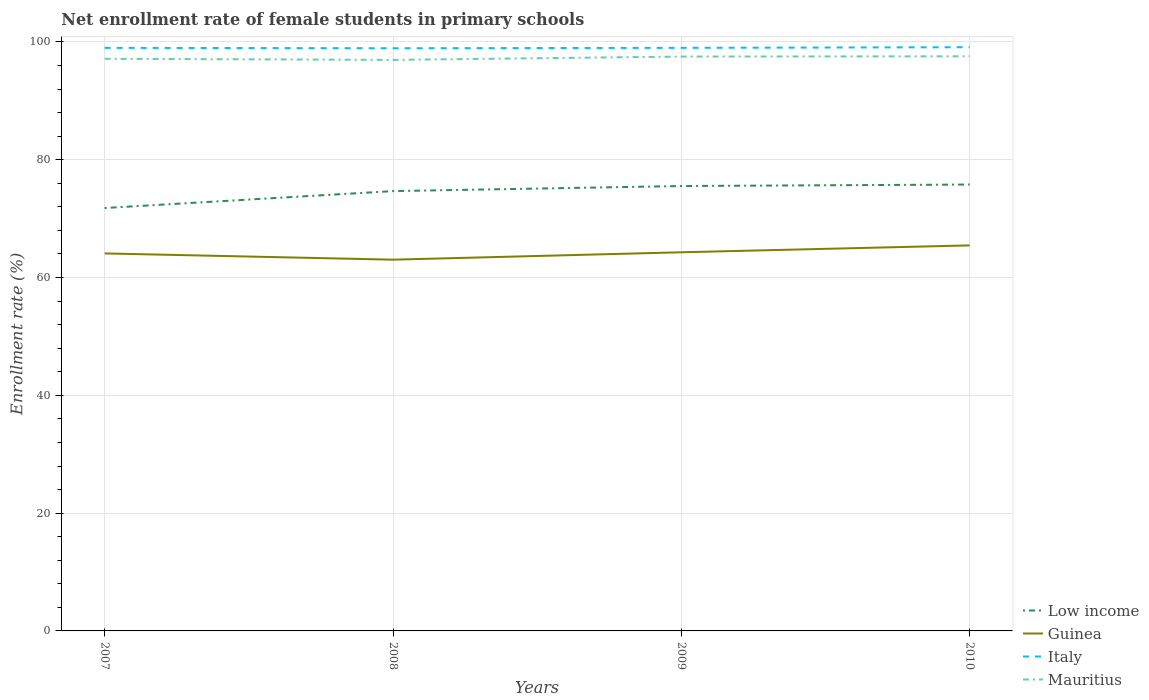Across all years, what is the maximum net enrollment rate of female students in primary schools in Low income?
Give a very brief answer. 71.81. In which year was the net enrollment rate of female students in primary schools in Low income maximum?
Make the answer very short. 2007. What is the total net enrollment rate of female students in primary schools in Guinea in the graph?
Offer a very short reply. -1.36. What is the difference between the highest and the second highest net enrollment rate of female students in primary schools in Guinea?
Give a very brief answer. 2.43. What is the difference between the highest and the lowest net enrollment rate of female students in primary schools in Mauritius?
Offer a very short reply. 2. Is the net enrollment rate of female students in primary schools in Low income strictly greater than the net enrollment rate of female students in primary schools in Italy over the years?
Ensure brevity in your answer.  Yes. How many lines are there?
Ensure brevity in your answer.  4. How many years are there in the graph?
Ensure brevity in your answer.  4. What is the difference between two consecutive major ticks on the Y-axis?
Give a very brief answer. 20. Does the graph contain any zero values?
Provide a succinct answer. No. Does the graph contain grids?
Keep it short and to the point. Yes. How many legend labels are there?
Your response must be concise. 4. What is the title of the graph?
Your answer should be very brief. Net enrollment rate of female students in primary schools. Does "Dominican Republic" appear as one of the legend labels in the graph?
Offer a terse response. No. What is the label or title of the Y-axis?
Offer a very short reply. Enrollment rate (%). What is the Enrollment rate (%) in Low income in 2007?
Ensure brevity in your answer.  71.81. What is the Enrollment rate (%) of Guinea in 2007?
Your answer should be very brief. 64.1. What is the Enrollment rate (%) of Italy in 2007?
Keep it short and to the point. 99. What is the Enrollment rate (%) in Mauritius in 2007?
Keep it short and to the point. 97.15. What is the Enrollment rate (%) in Low income in 2008?
Your response must be concise. 74.68. What is the Enrollment rate (%) in Guinea in 2008?
Offer a terse response. 63.04. What is the Enrollment rate (%) in Italy in 2008?
Provide a short and direct response. 98.94. What is the Enrollment rate (%) in Mauritius in 2008?
Make the answer very short. 96.96. What is the Enrollment rate (%) of Low income in 2009?
Your answer should be very brief. 75.54. What is the Enrollment rate (%) in Guinea in 2009?
Offer a very short reply. 64.29. What is the Enrollment rate (%) in Italy in 2009?
Your answer should be compact. 99.01. What is the Enrollment rate (%) of Mauritius in 2009?
Offer a terse response. 97.52. What is the Enrollment rate (%) in Low income in 2010?
Provide a short and direct response. 75.79. What is the Enrollment rate (%) in Guinea in 2010?
Your response must be concise. 65.46. What is the Enrollment rate (%) of Italy in 2010?
Provide a succinct answer. 99.11. What is the Enrollment rate (%) in Mauritius in 2010?
Offer a terse response. 97.57. Across all years, what is the maximum Enrollment rate (%) in Low income?
Offer a very short reply. 75.79. Across all years, what is the maximum Enrollment rate (%) of Guinea?
Keep it short and to the point. 65.46. Across all years, what is the maximum Enrollment rate (%) in Italy?
Make the answer very short. 99.11. Across all years, what is the maximum Enrollment rate (%) in Mauritius?
Provide a short and direct response. 97.57. Across all years, what is the minimum Enrollment rate (%) of Low income?
Your response must be concise. 71.81. Across all years, what is the minimum Enrollment rate (%) in Guinea?
Keep it short and to the point. 63.04. Across all years, what is the minimum Enrollment rate (%) in Italy?
Ensure brevity in your answer.  98.94. Across all years, what is the minimum Enrollment rate (%) of Mauritius?
Your response must be concise. 96.96. What is the total Enrollment rate (%) of Low income in the graph?
Provide a succinct answer. 297.82. What is the total Enrollment rate (%) of Guinea in the graph?
Offer a very short reply. 256.89. What is the total Enrollment rate (%) in Italy in the graph?
Ensure brevity in your answer.  396.06. What is the total Enrollment rate (%) in Mauritius in the graph?
Your response must be concise. 389.2. What is the difference between the Enrollment rate (%) in Low income in 2007 and that in 2008?
Offer a terse response. -2.87. What is the difference between the Enrollment rate (%) of Guinea in 2007 and that in 2008?
Offer a terse response. 1.06. What is the difference between the Enrollment rate (%) in Italy in 2007 and that in 2008?
Keep it short and to the point. 0.07. What is the difference between the Enrollment rate (%) of Mauritius in 2007 and that in 2008?
Offer a terse response. 0.18. What is the difference between the Enrollment rate (%) in Low income in 2007 and that in 2009?
Keep it short and to the point. -3.74. What is the difference between the Enrollment rate (%) in Guinea in 2007 and that in 2009?
Your answer should be compact. -0.19. What is the difference between the Enrollment rate (%) in Italy in 2007 and that in 2009?
Make the answer very short. -0. What is the difference between the Enrollment rate (%) in Mauritius in 2007 and that in 2009?
Your answer should be very brief. -0.38. What is the difference between the Enrollment rate (%) of Low income in 2007 and that in 2010?
Ensure brevity in your answer.  -3.99. What is the difference between the Enrollment rate (%) in Guinea in 2007 and that in 2010?
Your response must be concise. -1.36. What is the difference between the Enrollment rate (%) in Italy in 2007 and that in 2010?
Provide a succinct answer. -0.11. What is the difference between the Enrollment rate (%) of Mauritius in 2007 and that in 2010?
Ensure brevity in your answer.  -0.42. What is the difference between the Enrollment rate (%) in Low income in 2008 and that in 2009?
Make the answer very short. -0.86. What is the difference between the Enrollment rate (%) of Guinea in 2008 and that in 2009?
Keep it short and to the point. -1.25. What is the difference between the Enrollment rate (%) of Italy in 2008 and that in 2009?
Give a very brief answer. -0.07. What is the difference between the Enrollment rate (%) of Mauritius in 2008 and that in 2009?
Offer a terse response. -0.56. What is the difference between the Enrollment rate (%) of Low income in 2008 and that in 2010?
Your answer should be very brief. -1.11. What is the difference between the Enrollment rate (%) of Guinea in 2008 and that in 2010?
Your answer should be very brief. -2.43. What is the difference between the Enrollment rate (%) in Italy in 2008 and that in 2010?
Offer a very short reply. -0.18. What is the difference between the Enrollment rate (%) in Mauritius in 2008 and that in 2010?
Provide a short and direct response. -0.61. What is the difference between the Enrollment rate (%) of Low income in 2009 and that in 2010?
Provide a succinct answer. -0.25. What is the difference between the Enrollment rate (%) of Guinea in 2009 and that in 2010?
Your answer should be very brief. -1.17. What is the difference between the Enrollment rate (%) in Italy in 2009 and that in 2010?
Offer a terse response. -0.11. What is the difference between the Enrollment rate (%) in Mauritius in 2009 and that in 2010?
Provide a succinct answer. -0.05. What is the difference between the Enrollment rate (%) of Low income in 2007 and the Enrollment rate (%) of Guinea in 2008?
Your answer should be compact. 8.77. What is the difference between the Enrollment rate (%) of Low income in 2007 and the Enrollment rate (%) of Italy in 2008?
Your answer should be very brief. -27.13. What is the difference between the Enrollment rate (%) of Low income in 2007 and the Enrollment rate (%) of Mauritius in 2008?
Your response must be concise. -25.15. What is the difference between the Enrollment rate (%) of Guinea in 2007 and the Enrollment rate (%) of Italy in 2008?
Make the answer very short. -34.84. What is the difference between the Enrollment rate (%) of Guinea in 2007 and the Enrollment rate (%) of Mauritius in 2008?
Provide a succinct answer. -32.86. What is the difference between the Enrollment rate (%) in Italy in 2007 and the Enrollment rate (%) in Mauritius in 2008?
Your response must be concise. 2.04. What is the difference between the Enrollment rate (%) of Low income in 2007 and the Enrollment rate (%) of Guinea in 2009?
Your response must be concise. 7.52. What is the difference between the Enrollment rate (%) of Low income in 2007 and the Enrollment rate (%) of Italy in 2009?
Offer a very short reply. -27.2. What is the difference between the Enrollment rate (%) in Low income in 2007 and the Enrollment rate (%) in Mauritius in 2009?
Offer a terse response. -25.71. What is the difference between the Enrollment rate (%) in Guinea in 2007 and the Enrollment rate (%) in Italy in 2009?
Give a very brief answer. -34.91. What is the difference between the Enrollment rate (%) of Guinea in 2007 and the Enrollment rate (%) of Mauritius in 2009?
Provide a short and direct response. -33.42. What is the difference between the Enrollment rate (%) of Italy in 2007 and the Enrollment rate (%) of Mauritius in 2009?
Offer a very short reply. 1.48. What is the difference between the Enrollment rate (%) of Low income in 2007 and the Enrollment rate (%) of Guinea in 2010?
Ensure brevity in your answer.  6.34. What is the difference between the Enrollment rate (%) in Low income in 2007 and the Enrollment rate (%) in Italy in 2010?
Provide a succinct answer. -27.31. What is the difference between the Enrollment rate (%) of Low income in 2007 and the Enrollment rate (%) of Mauritius in 2010?
Make the answer very short. -25.76. What is the difference between the Enrollment rate (%) in Guinea in 2007 and the Enrollment rate (%) in Italy in 2010?
Give a very brief answer. -35.02. What is the difference between the Enrollment rate (%) in Guinea in 2007 and the Enrollment rate (%) in Mauritius in 2010?
Provide a succinct answer. -33.47. What is the difference between the Enrollment rate (%) of Italy in 2007 and the Enrollment rate (%) of Mauritius in 2010?
Make the answer very short. 1.43. What is the difference between the Enrollment rate (%) in Low income in 2008 and the Enrollment rate (%) in Guinea in 2009?
Offer a terse response. 10.39. What is the difference between the Enrollment rate (%) of Low income in 2008 and the Enrollment rate (%) of Italy in 2009?
Your response must be concise. -24.33. What is the difference between the Enrollment rate (%) of Low income in 2008 and the Enrollment rate (%) of Mauritius in 2009?
Your answer should be very brief. -22.84. What is the difference between the Enrollment rate (%) of Guinea in 2008 and the Enrollment rate (%) of Italy in 2009?
Offer a terse response. -35.97. What is the difference between the Enrollment rate (%) in Guinea in 2008 and the Enrollment rate (%) in Mauritius in 2009?
Your response must be concise. -34.48. What is the difference between the Enrollment rate (%) of Italy in 2008 and the Enrollment rate (%) of Mauritius in 2009?
Offer a very short reply. 1.41. What is the difference between the Enrollment rate (%) in Low income in 2008 and the Enrollment rate (%) in Guinea in 2010?
Ensure brevity in your answer.  9.22. What is the difference between the Enrollment rate (%) in Low income in 2008 and the Enrollment rate (%) in Italy in 2010?
Ensure brevity in your answer.  -24.43. What is the difference between the Enrollment rate (%) in Low income in 2008 and the Enrollment rate (%) in Mauritius in 2010?
Your answer should be compact. -22.89. What is the difference between the Enrollment rate (%) in Guinea in 2008 and the Enrollment rate (%) in Italy in 2010?
Provide a short and direct response. -36.08. What is the difference between the Enrollment rate (%) of Guinea in 2008 and the Enrollment rate (%) of Mauritius in 2010?
Make the answer very short. -34.53. What is the difference between the Enrollment rate (%) in Italy in 2008 and the Enrollment rate (%) in Mauritius in 2010?
Provide a short and direct response. 1.37. What is the difference between the Enrollment rate (%) in Low income in 2009 and the Enrollment rate (%) in Guinea in 2010?
Offer a terse response. 10.08. What is the difference between the Enrollment rate (%) of Low income in 2009 and the Enrollment rate (%) of Italy in 2010?
Ensure brevity in your answer.  -23.57. What is the difference between the Enrollment rate (%) in Low income in 2009 and the Enrollment rate (%) in Mauritius in 2010?
Provide a succinct answer. -22.03. What is the difference between the Enrollment rate (%) in Guinea in 2009 and the Enrollment rate (%) in Italy in 2010?
Offer a very short reply. -34.82. What is the difference between the Enrollment rate (%) of Guinea in 2009 and the Enrollment rate (%) of Mauritius in 2010?
Ensure brevity in your answer.  -33.28. What is the difference between the Enrollment rate (%) of Italy in 2009 and the Enrollment rate (%) of Mauritius in 2010?
Provide a short and direct response. 1.44. What is the average Enrollment rate (%) of Low income per year?
Offer a very short reply. 74.46. What is the average Enrollment rate (%) of Guinea per year?
Provide a succinct answer. 64.22. What is the average Enrollment rate (%) in Italy per year?
Your answer should be very brief. 99.02. What is the average Enrollment rate (%) in Mauritius per year?
Ensure brevity in your answer.  97.3. In the year 2007, what is the difference between the Enrollment rate (%) in Low income and Enrollment rate (%) in Guinea?
Your response must be concise. 7.71. In the year 2007, what is the difference between the Enrollment rate (%) of Low income and Enrollment rate (%) of Italy?
Make the answer very short. -27.2. In the year 2007, what is the difference between the Enrollment rate (%) in Low income and Enrollment rate (%) in Mauritius?
Give a very brief answer. -25.34. In the year 2007, what is the difference between the Enrollment rate (%) of Guinea and Enrollment rate (%) of Italy?
Provide a succinct answer. -34.91. In the year 2007, what is the difference between the Enrollment rate (%) in Guinea and Enrollment rate (%) in Mauritius?
Your answer should be compact. -33.05. In the year 2007, what is the difference between the Enrollment rate (%) in Italy and Enrollment rate (%) in Mauritius?
Offer a very short reply. 1.86. In the year 2008, what is the difference between the Enrollment rate (%) of Low income and Enrollment rate (%) of Guinea?
Ensure brevity in your answer.  11.64. In the year 2008, what is the difference between the Enrollment rate (%) of Low income and Enrollment rate (%) of Italy?
Provide a succinct answer. -24.26. In the year 2008, what is the difference between the Enrollment rate (%) in Low income and Enrollment rate (%) in Mauritius?
Your response must be concise. -22.28. In the year 2008, what is the difference between the Enrollment rate (%) of Guinea and Enrollment rate (%) of Italy?
Offer a very short reply. -35.9. In the year 2008, what is the difference between the Enrollment rate (%) of Guinea and Enrollment rate (%) of Mauritius?
Your response must be concise. -33.92. In the year 2008, what is the difference between the Enrollment rate (%) of Italy and Enrollment rate (%) of Mauritius?
Keep it short and to the point. 1.97. In the year 2009, what is the difference between the Enrollment rate (%) of Low income and Enrollment rate (%) of Guinea?
Your response must be concise. 11.25. In the year 2009, what is the difference between the Enrollment rate (%) of Low income and Enrollment rate (%) of Italy?
Provide a short and direct response. -23.47. In the year 2009, what is the difference between the Enrollment rate (%) of Low income and Enrollment rate (%) of Mauritius?
Your answer should be compact. -21.98. In the year 2009, what is the difference between the Enrollment rate (%) of Guinea and Enrollment rate (%) of Italy?
Ensure brevity in your answer.  -34.72. In the year 2009, what is the difference between the Enrollment rate (%) in Guinea and Enrollment rate (%) in Mauritius?
Give a very brief answer. -33.23. In the year 2009, what is the difference between the Enrollment rate (%) of Italy and Enrollment rate (%) of Mauritius?
Your answer should be compact. 1.49. In the year 2010, what is the difference between the Enrollment rate (%) in Low income and Enrollment rate (%) in Guinea?
Ensure brevity in your answer.  10.33. In the year 2010, what is the difference between the Enrollment rate (%) in Low income and Enrollment rate (%) in Italy?
Offer a terse response. -23.32. In the year 2010, what is the difference between the Enrollment rate (%) of Low income and Enrollment rate (%) of Mauritius?
Offer a terse response. -21.78. In the year 2010, what is the difference between the Enrollment rate (%) in Guinea and Enrollment rate (%) in Italy?
Your answer should be very brief. -33.65. In the year 2010, what is the difference between the Enrollment rate (%) of Guinea and Enrollment rate (%) of Mauritius?
Offer a very short reply. -32.11. In the year 2010, what is the difference between the Enrollment rate (%) in Italy and Enrollment rate (%) in Mauritius?
Provide a succinct answer. 1.54. What is the ratio of the Enrollment rate (%) in Low income in 2007 to that in 2008?
Your answer should be very brief. 0.96. What is the ratio of the Enrollment rate (%) in Guinea in 2007 to that in 2008?
Ensure brevity in your answer.  1.02. What is the ratio of the Enrollment rate (%) of Italy in 2007 to that in 2008?
Provide a succinct answer. 1. What is the ratio of the Enrollment rate (%) in Low income in 2007 to that in 2009?
Your answer should be compact. 0.95. What is the ratio of the Enrollment rate (%) of Italy in 2007 to that in 2009?
Make the answer very short. 1. What is the ratio of the Enrollment rate (%) in Low income in 2007 to that in 2010?
Give a very brief answer. 0.95. What is the ratio of the Enrollment rate (%) in Guinea in 2007 to that in 2010?
Your answer should be compact. 0.98. What is the ratio of the Enrollment rate (%) of Italy in 2007 to that in 2010?
Keep it short and to the point. 1. What is the ratio of the Enrollment rate (%) in Low income in 2008 to that in 2009?
Keep it short and to the point. 0.99. What is the ratio of the Enrollment rate (%) in Guinea in 2008 to that in 2009?
Make the answer very short. 0.98. What is the ratio of the Enrollment rate (%) in Mauritius in 2008 to that in 2009?
Your answer should be compact. 0.99. What is the ratio of the Enrollment rate (%) in Guinea in 2008 to that in 2010?
Your response must be concise. 0.96. What is the ratio of the Enrollment rate (%) of Mauritius in 2008 to that in 2010?
Your answer should be very brief. 0.99. What is the ratio of the Enrollment rate (%) in Guinea in 2009 to that in 2010?
Your answer should be compact. 0.98. What is the ratio of the Enrollment rate (%) of Italy in 2009 to that in 2010?
Your response must be concise. 1. What is the ratio of the Enrollment rate (%) of Mauritius in 2009 to that in 2010?
Keep it short and to the point. 1. What is the difference between the highest and the second highest Enrollment rate (%) in Low income?
Offer a very short reply. 0.25. What is the difference between the highest and the second highest Enrollment rate (%) of Guinea?
Your answer should be very brief. 1.17. What is the difference between the highest and the second highest Enrollment rate (%) in Italy?
Offer a very short reply. 0.11. What is the difference between the highest and the second highest Enrollment rate (%) in Mauritius?
Make the answer very short. 0.05. What is the difference between the highest and the lowest Enrollment rate (%) in Low income?
Your answer should be compact. 3.99. What is the difference between the highest and the lowest Enrollment rate (%) of Guinea?
Your response must be concise. 2.43. What is the difference between the highest and the lowest Enrollment rate (%) of Italy?
Offer a very short reply. 0.18. What is the difference between the highest and the lowest Enrollment rate (%) of Mauritius?
Your answer should be compact. 0.61. 